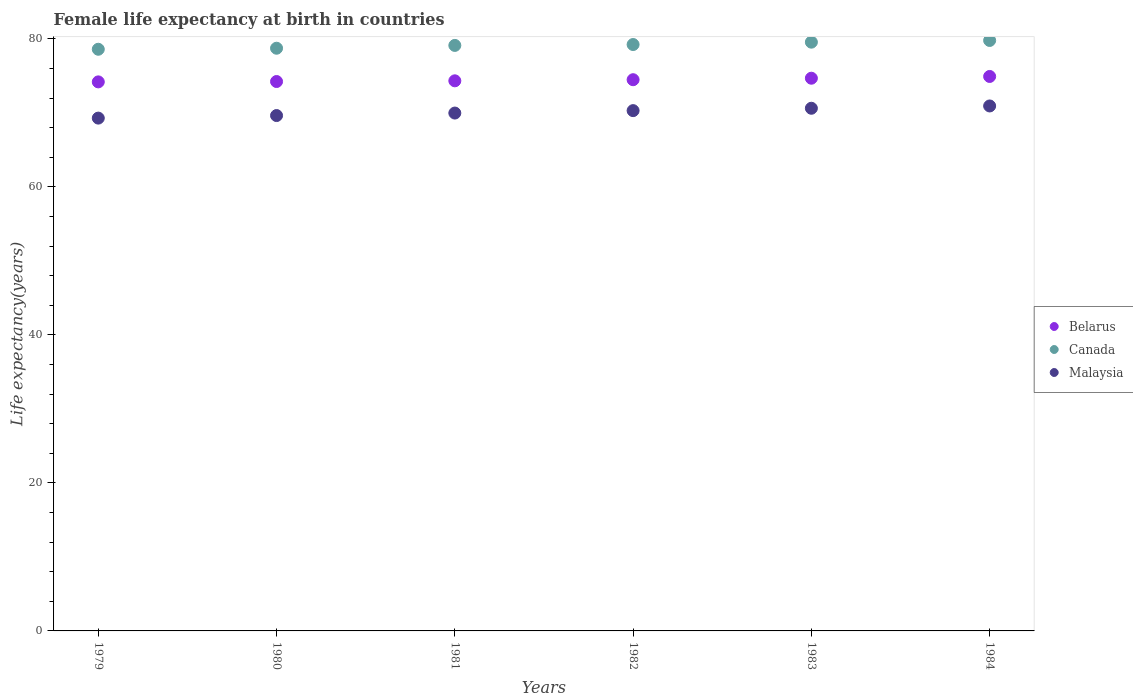What is the female life expectancy at birth in Belarus in 1984?
Make the answer very short. 74.92. Across all years, what is the maximum female life expectancy at birth in Belarus?
Offer a terse response. 74.92. Across all years, what is the minimum female life expectancy at birth in Belarus?
Offer a very short reply. 74.18. In which year was the female life expectancy at birth in Belarus minimum?
Keep it short and to the point. 1979. What is the total female life expectancy at birth in Belarus in the graph?
Keep it short and to the point. 446.81. What is the difference between the female life expectancy at birth in Canada in 1983 and that in 1984?
Provide a succinct answer. -0.23. What is the difference between the female life expectancy at birth in Canada in 1983 and the female life expectancy at birth in Malaysia in 1982?
Your response must be concise. 9.25. What is the average female life expectancy at birth in Canada per year?
Make the answer very short. 79.17. In the year 1982, what is the difference between the female life expectancy at birth in Canada and female life expectancy at birth in Malaysia?
Your answer should be very brief. 8.93. What is the ratio of the female life expectancy at birth in Belarus in 1982 to that in 1983?
Give a very brief answer. 1. Is the female life expectancy at birth in Canada in 1980 less than that in 1984?
Offer a very short reply. Yes. What is the difference between the highest and the second highest female life expectancy at birth in Belarus?
Ensure brevity in your answer.  0.24. What is the difference between the highest and the lowest female life expectancy at birth in Belarus?
Offer a terse response. 0.73. Is the sum of the female life expectancy at birth in Canada in 1979 and 1981 greater than the maximum female life expectancy at birth in Malaysia across all years?
Give a very brief answer. Yes. Does the female life expectancy at birth in Malaysia monotonically increase over the years?
Provide a short and direct response. Yes. How many dotlines are there?
Offer a very short reply. 3. How many years are there in the graph?
Provide a short and direct response. 6. Are the values on the major ticks of Y-axis written in scientific E-notation?
Offer a terse response. No. Does the graph contain any zero values?
Ensure brevity in your answer.  No. Where does the legend appear in the graph?
Provide a short and direct response. Center right. How many legend labels are there?
Your answer should be very brief. 3. What is the title of the graph?
Provide a short and direct response. Female life expectancy at birth in countries. Does "Sweden" appear as one of the legend labels in the graph?
Your answer should be compact. No. What is the label or title of the X-axis?
Your answer should be compact. Years. What is the label or title of the Y-axis?
Your response must be concise. Life expectancy(years). What is the Life expectancy(years) in Belarus in 1979?
Offer a terse response. 74.18. What is the Life expectancy(years) in Canada in 1979?
Provide a succinct answer. 78.59. What is the Life expectancy(years) of Malaysia in 1979?
Ensure brevity in your answer.  69.29. What is the Life expectancy(years) of Belarus in 1980?
Your response must be concise. 74.23. What is the Life expectancy(years) in Canada in 1980?
Provide a succinct answer. 78.73. What is the Life expectancy(years) in Malaysia in 1980?
Your answer should be very brief. 69.63. What is the Life expectancy(years) of Belarus in 1981?
Keep it short and to the point. 74.33. What is the Life expectancy(years) in Canada in 1981?
Ensure brevity in your answer.  79.11. What is the Life expectancy(years) of Malaysia in 1981?
Offer a very short reply. 69.97. What is the Life expectancy(years) of Belarus in 1982?
Provide a short and direct response. 74.48. What is the Life expectancy(years) in Canada in 1982?
Offer a very short reply. 79.23. What is the Life expectancy(years) in Malaysia in 1982?
Your answer should be compact. 70.3. What is the Life expectancy(years) of Belarus in 1983?
Provide a succinct answer. 74.68. What is the Life expectancy(years) of Canada in 1983?
Keep it short and to the point. 79.55. What is the Life expectancy(years) of Malaysia in 1983?
Make the answer very short. 70.62. What is the Life expectancy(years) of Belarus in 1984?
Offer a very short reply. 74.92. What is the Life expectancy(years) of Canada in 1984?
Keep it short and to the point. 79.78. What is the Life expectancy(years) of Malaysia in 1984?
Keep it short and to the point. 70.93. Across all years, what is the maximum Life expectancy(years) of Belarus?
Offer a terse response. 74.92. Across all years, what is the maximum Life expectancy(years) in Canada?
Offer a terse response. 79.78. Across all years, what is the maximum Life expectancy(years) in Malaysia?
Ensure brevity in your answer.  70.93. Across all years, what is the minimum Life expectancy(years) of Belarus?
Your answer should be compact. 74.18. Across all years, what is the minimum Life expectancy(years) of Canada?
Offer a very short reply. 78.59. Across all years, what is the minimum Life expectancy(years) of Malaysia?
Your answer should be compact. 69.29. What is the total Life expectancy(years) of Belarus in the graph?
Give a very brief answer. 446.81. What is the total Life expectancy(years) of Canada in the graph?
Ensure brevity in your answer.  474.99. What is the total Life expectancy(years) of Malaysia in the graph?
Your answer should be compact. 420.74. What is the difference between the Life expectancy(years) of Belarus in 1979 and that in 1980?
Provide a short and direct response. -0.05. What is the difference between the Life expectancy(years) of Canada in 1979 and that in 1980?
Your answer should be compact. -0.14. What is the difference between the Life expectancy(years) in Malaysia in 1979 and that in 1980?
Your answer should be compact. -0.35. What is the difference between the Life expectancy(years) of Belarus in 1979 and that in 1981?
Give a very brief answer. -0.14. What is the difference between the Life expectancy(years) of Canada in 1979 and that in 1981?
Ensure brevity in your answer.  -0.52. What is the difference between the Life expectancy(years) in Malaysia in 1979 and that in 1981?
Give a very brief answer. -0.68. What is the difference between the Life expectancy(years) of Belarus in 1979 and that in 1982?
Your answer should be very brief. -0.29. What is the difference between the Life expectancy(years) of Canada in 1979 and that in 1982?
Your answer should be compact. -0.64. What is the difference between the Life expectancy(years) in Malaysia in 1979 and that in 1982?
Make the answer very short. -1.01. What is the difference between the Life expectancy(years) in Belarus in 1979 and that in 1983?
Make the answer very short. -0.49. What is the difference between the Life expectancy(years) in Canada in 1979 and that in 1983?
Provide a succinct answer. -0.96. What is the difference between the Life expectancy(years) in Malaysia in 1979 and that in 1983?
Keep it short and to the point. -1.33. What is the difference between the Life expectancy(years) of Belarus in 1979 and that in 1984?
Make the answer very short. -0.73. What is the difference between the Life expectancy(years) in Canada in 1979 and that in 1984?
Offer a terse response. -1.19. What is the difference between the Life expectancy(years) of Malaysia in 1979 and that in 1984?
Keep it short and to the point. -1.64. What is the difference between the Life expectancy(years) of Belarus in 1980 and that in 1981?
Provide a short and direct response. -0.1. What is the difference between the Life expectancy(years) in Canada in 1980 and that in 1981?
Make the answer very short. -0.38. What is the difference between the Life expectancy(years) of Malaysia in 1980 and that in 1981?
Make the answer very short. -0.34. What is the difference between the Life expectancy(years) of Belarus in 1980 and that in 1982?
Make the answer very short. -0.24. What is the difference between the Life expectancy(years) of Canada in 1980 and that in 1982?
Your answer should be very brief. -0.5. What is the difference between the Life expectancy(years) of Malaysia in 1980 and that in 1982?
Your answer should be very brief. -0.67. What is the difference between the Life expectancy(years) in Belarus in 1980 and that in 1983?
Ensure brevity in your answer.  -0.45. What is the difference between the Life expectancy(years) in Canada in 1980 and that in 1983?
Your answer should be compact. -0.82. What is the difference between the Life expectancy(years) in Malaysia in 1980 and that in 1983?
Provide a succinct answer. -0.98. What is the difference between the Life expectancy(years) of Belarus in 1980 and that in 1984?
Give a very brief answer. -0.68. What is the difference between the Life expectancy(years) of Canada in 1980 and that in 1984?
Offer a terse response. -1.05. What is the difference between the Life expectancy(years) in Malaysia in 1980 and that in 1984?
Provide a succinct answer. -1.3. What is the difference between the Life expectancy(years) of Belarus in 1981 and that in 1982?
Your response must be concise. -0.15. What is the difference between the Life expectancy(years) in Canada in 1981 and that in 1982?
Make the answer very short. -0.12. What is the difference between the Life expectancy(years) of Malaysia in 1981 and that in 1982?
Offer a terse response. -0.33. What is the difference between the Life expectancy(years) in Belarus in 1981 and that in 1983?
Give a very brief answer. -0.35. What is the difference between the Life expectancy(years) of Canada in 1981 and that in 1983?
Your answer should be very brief. -0.44. What is the difference between the Life expectancy(years) of Malaysia in 1981 and that in 1983?
Give a very brief answer. -0.65. What is the difference between the Life expectancy(years) in Belarus in 1981 and that in 1984?
Provide a short and direct response. -0.59. What is the difference between the Life expectancy(years) of Canada in 1981 and that in 1984?
Your response must be concise. -0.67. What is the difference between the Life expectancy(years) in Malaysia in 1981 and that in 1984?
Your response must be concise. -0.96. What is the difference between the Life expectancy(years) of Belarus in 1982 and that in 1983?
Offer a terse response. -0.2. What is the difference between the Life expectancy(years) in Canada in 1982 and that in 1983?
Provide a succinct answer. -0.32. What is the difference between the Life expectancy(years) of Malaysia in 1982 and that in 1983?
Offer a very short reply. -0.32. What is the difference between the Life expectancy(years) of Belarus in 1982 and that in 1984?
Provide a succinct answer. -0.44. What is the difference between the Life expectancy(years) in Canada in 1982 and that in 1984?
Provide a short and direct response. -0.55. What is the difference between the Life expectancy(years) in Malaysia in 1982 and that in 1984?
Your response must be concise. -0.63. What is the difference between the Life expectancy(years) of Belarus in 1983 and that in 1984?
Offer a terse response. -0.24. What is the difference between the Life expectancy(years) of Canada in 1983 and that in 1984?
Offer a very short reply. -0.23. What is the difference between the Life expectancy(years) in Malaysia in 1983 and that in 1984?
Provide a short and direct response. -0.31. What is the difference between the Life expectancy(years) of Belarus in 1979 and the Life expectancy(years) of Canada in 1980?
Provide a succinct answer. -4.55. What is the difference between the Life expectancy(years) of Belarus in 1979 and the Life expectancy(years) of Malaysia in 1980?
Offer a terse response. 4.55. What is the difference between the Life expectancy(years) in Canada in 1979 and the Life expectancy(years) in Malaysia in 1980?
Provide a succinct answer. 8.96. What is the difference between the Life expectancy(years) of Belarus in 1979 and the Life expectancy(years) of Canada in 1981?
Offer a terse response. -4.93. What is the difference between the Life expectancy(years) of Belarus in 1979 and the Life expectancy(years) of Malaysia in 1981?
Offer a very short reply. 4.21. What is the difference between the Life expectancy(years) in Canada in 1979 and the Life expectancy(years) in Malaysia in 1981?
Give a very brief answer. 8.62. What is the difference between the Life expectancy(years) in Belarus in 1979 and the Life expectancy(years) in Canada in 1982?
Make the answer very short. -5.05. What is the difference between the Life expectancy(years) in Belarus in 1979 and the Life expectancy(years) in Malaysia in 1982?
Your answer should be compact. 3.88. What is the difference between the Life expectancy(years) in Canada in 1979 and the Life expectancy(years) in Malaysia in 1982?
Your answer should be compact. 8.29. What is the difference between the Life expectancy(years) of Belarus in 1979 and the Life expectancy(years) of Canada in 1983?
Provide a succinct answer. -5.37. What is the difference between the Life expectancy(years) of Belarus in 1979 and the Life expectancy(years) of Malaysia in 1983?
Your response must be concise. 3.56. What is the difference between the Life expectancy(years) of Canada in 1979 and the Life expectancy(years) of Malaysia in 1983?
Your answer should be very brief. 7.97. What is the difference between the Life expectancy(years) of Belarus in 1979 and the Life expectancy(years) of Canada in 1984?
Ensure brevity in your answer.  -5.6. What is the difference between the Life expectancy(years) in Belarus in 1979 and the Life expectancy(years) in Malaysia in 1984?
Make the answer very short. 3.25. What is the difference between the Life expectancy(years) of Canada in 1979 and the Life expectancy(years) of Malaysia in 1984?
Ensure brevity in your answer.  7.66. What is the difference between the Life expectancy(years) in Belarus in 1980 and the Life expectancy(years) in Canada in 1981?
Ensure brevity in your answer.  -4.88. What is the difference between the Life expectancy(years) in Belarus in 1980 and the Life expectancy(years) in Malaysia in 1981?
Your response must be concise. 4.26. What is the difference between the Life expectancy(years) in Canada in 1980 and the Life expectancy(years) in Malaysia in 1981?
Your answer should be compact. 8.76. What is the difference between the Life expectancy(years) of Belarus in 1980 and the Life expectancy(years) of Canada in 1982?
Provide a succinct answer. -5. What is the difference between the Life expectancy(years) of Belarus in 1980 and the Life expectancy(years) of Malaysia in 1982?
Offer a terse response. 3.93. What is the difference between the Life expectancy(years) in Canada in 1980 and the Life expectancy(years) in Malaysia in 1982?
Ensure brevity in your answer.  8.43. What is the difference between the Life expectancy(years) of Belarus in 1980 and the Life expectancy(years) of Canada in 1983?
Make the answer very short. -5.32. What is the difference between the Life expectancy(years) in Belarus in 1980 and the Life expectancy(years) in Malaysia in 1983?
Your answer should be compact. 3.61. What is the difference between the Life expectancy(years) in Canada in 1980 and the Life expectancy(years) in Malaysia in 1983?
Keep it short and to the point. 8.11. What is the difference between the Life expectancy(years) of Belarus in 1980 and the Life expectancy(years) of Canada in 1984?
Provide a short and direct response. -5.55. What is the difference between the Life expectancy(years) of Belarus in 1980 and the Life expectancy(years) of Malaysia in 1984?
Your answer should be compact. 3.3. What is the difference between the Life expectancy(years) of Belarus in 1981 and the Life expectancy(years) of Canada in 1982?
Provide a succinct answer. -4.9. What is the difference between the Life expectancy(years) in Belarus in 1981 and the Life expectancy(years) in Malaysia in 1982?
Offer a very short reply. 4.03. What is the difference between the Life expectancy(years) of Canada in 1981 and the Life expectancy(years) of Malaysia in 1982?
Ensure brevity in your answer.  8.81. What is the difference between the Life expectancy(years) of Belarus in 1981 and the Life expectancy(years) of Canada in 1983?
Offer a very short reply. -5.22. What is the difference between the Life expectancy(years) in Belarus in 1981 and the Life expectancy(years) in Malaysia in 1983?
Provide a short and direct response. 3.71. What is the difference between the Life expectancy(years) in Canada in 1981 and the Life expectancy(years) in Malaysia in 1983?
Keep it short and to the point. 8.49. What is the difference between the Life expectancy(years) of Belarus in 1981 and the Life expectancy(years) of Canada in 1984?
Offer a very short reply. -5.45. What is the difference between the Life expectancy(years) in Belarus in 1981 and the Life expectancy(years) in Malaysia in 1984?
Give a very brief answer. 3.4. What is the difference between the Life expectancy(years) of Canada in 1981 and the Life expectancy(years) of Malaysia in 1984?
Your response must be concise. 8.18. What is the difference between the Life expectancy(years) of Belarus in 1982 and the Life expectancy(years) of Canada in 1983?
Provide a succinct answer. -5.07. What is the difference between the Life expectancy(years) in Belarus in 1982 and the Life expectancy(years) in Malaysia in 1983?
Offer a terse response. 3.86. What is the difference between the Life expectancy(years) in Canada in 1982 and the Life expectancy(years) in Malaysia in 1983?
Your answer should be compact. 8.61. What is the difference between the Life expectancy(years) of Belarus in 1982 and the Life expectancy(years) of Canada in 1984?
Make the answer very short. -5.3. What is the difference between the Life expectancy(years) of Belarus in 1982 and the Life expectancy(years) of Malaysia in 1984?
Make the answer very short. 3.55. What is the difference between the Life expectancy(years) of Belarus in 1983 and the Life expectancy(years) of Canada in 1984?
Your response must be concise. -5.1. What is the difference between the Life expectancy(years) in Belarus in 1983 and the Life expectancy(years) in Malaysia in 1984?
Your answer should be very brief. 3.75. What is the difference between the Life expectancy(years) in Canada in 1983 and the Life expectancy(years) in Malaysia in 1984?
Provide a succinct answer. 8.62. What is the average Life expectancy(years) of Belarus per year?
Make the answer very short. 74.47. What is the average Life expectancy(years) of Canada per year?
Offer a terse response. 79.17. What is the average Life expectancy(years) in Malaysia per year?
Ensure brevity in your answer.  70.12. In the year 1979, what is the difference between the Life expectancy(years) of Belarus and Life expectancy(years) of Canada?
Offer a very short reply. -4.41. In the year 1979, what is the difference between the Life expectancy(years) in Belarus and Life expectancy(years) in Malaysia?
Your response must be concise. 4.89. In the year 1979, what is the difference between the Life expectancy(years) in Canada and Life expectancy(years) in Malaysia?
Provide a short and direct response. 9.3. In the year 1980, what is the difference between the Life expectancy(years) in Belarus and Life expectancy(years) in Canada?
Your response must be concise. -4.5. In the year 1980, what is the difference between the Life expectancy(years) of Belarus and Life expectancy(years) of Malaysia?
Give a very brief answer. 4.6. In the year 1980, what is the difference between the Life expectancy(years) in Canada and Life expectancy(years) in Malaysia?
Your answer should be compact. 9.1. In the year 1981, what is the difference between the Life expectancy(years) in Belarus and Life expectancy(years) in Canada?
Your answer should be very brief. -4.78. In the year 1981, what is the difference between the Life expectancy(years) of Belarus and Life expectancy(years) of Malaysia?
Your answer should be very brief. 4.36. In the year 1981, what is the difference between the Life expectancy(years) of Canada and Life expectancy(years) of Malaysia?
Provide a short and direct response. 9.14. In the year 1982, what is the difference between the Life expectancy(years) in Belarus and Life expectancy(years) in Canada?
Your answer should be compact. -4.75. In the year 1982, what is the difference between the Life expectancy(years) of Belarus and Life expectancy(years) of Malaysia?
Your answer should be very brief. 4.18. In the year 1982, what is the difference between the Life expectancy(years) in Canada and Life expectancy(years) in Malaysia?
Give a very brief answer. 8.93. In the year 1983, what is the difference between the Life expectancy(years) of Belarus and Life expectancy(years) of Canada?
Your answer should be compact. -4.87. In the year 1983, what is the difference between the Life expectancy(years) in Belarus and Life expectancy(years) in Malaysia?
Offer a terse response. 4.06. In the year 1983, what is the difference between the Life expectancy(years) of Canada and Life expectancy(years) of Malaysia?
Your answer should be compact. 8.93. In the year 1984, what is the difference between the Life expectancy(years) of Belarus and Life expectancy(years) of Canada?
Make the answer very short. -4.86. In the year 1984, what is the difference between the Life expectancy(years) of Belarus and Life expectancy(years) of Malaysia?
Your response must be concise. 3.99. In the year 1984, what is the difference between the Life expectancy(years) of Canada and Life expectancy(years) of Malaysia?
Your answer should be very brief. 8.85. What is the ratio of the Life expectancy(years) of Canada in 1979 to that in 1980?
Give a very brief answer. 1. What is the ratio of the Life expectancy(years) in Malaysia in 1979 to that in 1980?
Offer a very short reply. 0.99. What is the ratio of the Life expectancy(years) in Canada in 1979 to that in 1981?
Provide a succinct answer. 0.99. What is the ratio of the Life expectancy(years) of Malaysia in 1979 to that in 1981?
Make the answer very short. 0.99. What is the ratio of the Life expectancy(years) in Malaysia in 1979 to that in 1982?
Keep it short and to the point. 0.99. What is the ratio of the Life expectancy(years) of Belarus in 1979 to that in 1983?
Keep it short and to the point. 0.99. What is the ratio of the Life expectancy(years) of Canada in 1979 to that in 1983?
Your response must be concise. 0.99. What is the ratio of the Life expectancy(years) in Malaysia in 1979 to that in 1983?
Your answer should be very brief. 0.98. What is the ratio of the Life expectancy(years) in Belarus in 1979 to that in 1984?
Your answer should be compact. 0.99. What is the ratio of the Life expectancy(years) of Canada in 1979 to that in 1984?
Your response must be concise. 0.99. What is the ratio of the Life expectancy(years) in Malaysia in 1979 to that in 1984?
Your answer should be compact. 0.98. What is the ratio of the Life expectancy(years) in Canada in 1980 to that in 1981?
Make the answer very short. 1. What is the ratio of the Life expectancy(years) in Malaysia in 1980 to that in 1981?
Your response must be concise. 1. What is the ratio of the Life expectancy(years) in Belarus in 1980 to that in 1982?
Give a very brief answer. 1. What is the ratio of the Life expectancy(years) in Malaysia in 1980 to that in 1982?
Give a very brief answer. 0.99. What is the ratio of the Life expectancy(years) of Belarus in 1980 to that in 1983?
Provide a short and direct response. 0.99. What is the ratio of the Life expectancy(years) of Canada in 1980 to that in 1983?
Give a very brief answer. 0.99. What is the ratio of the Life expectancy(years) in Malaysia in 1980 to that in 1983?
Ensure brevity in your answer.  0.99. What is the ratio of the Life expectancy(years) of Belarus in 1980 to that in 1984?
Your answer should be compact. 0.99. What is the ratio of the Life expectancy(years) of Canada in 1980 to that in 1984?
Your response must be concise. 0.99. What is the ratio of the Life expectancy(years) in Malaysia in 1980 to that in 1984?
Give a very brief answer. 0.98. What is the ratio of the Life expectancy(years) of Belarus in 1981 to that in 1983?
Your answer should be compact. 1. What is the ratio of the Life expectancy(years) in Canada in 1981 to that in 1983?
Ensure brevity in your answer.  0.99. What is the ratio of the Life expectancy(years) of Belarus in 1981 to that in 1984?
Provide a short and direct response. 0.99. What is the ratio of the Life expectancy(years) in Malaysia in 1981 to that in 1984?
Offer a very short reply. 0.99. What is the ratio of the Life expectancy(years) of Belarus in 1982 to that in 1983?
Offer a terse response. 1. What is the ratio of the Life expectancy(years) of Canada in 1982 to that in 1984?
Ensure brevity in your answer.  0.99. What is the ratio of the Life expectancy(years) of Belarus in 1983 to that in 1984?
Provide a short and direct response. 1. What is the ratio of the Life expectancy(years) of Canada in 1983 to that in 1984?
Your answer should be compact. 1. What is the difference between the highest and the second highest Life expectancy(years) in Belarus?
Your response must be concise. 0.24. What is the difference between the highest and the second highest Life expectancy(years) of Canada?
Give a very brief answer. 0.23. What is the difference between the highest and the second highest Life expectancy(years) in Malaysia?
Offer a terse response. 0.31. What is the difference between the highest and the lowest Life expectancy(years) in Belarus?
Provide a succinct answer. 0.73. What is the difference between the highest and the lowest Life expectancy(years) of Canada?
Offer a very short reply. 1.19. What is the difference between the highest and the lowest Life expectancy(years) of Malaysia?
Your response must be concise. 1.64. 